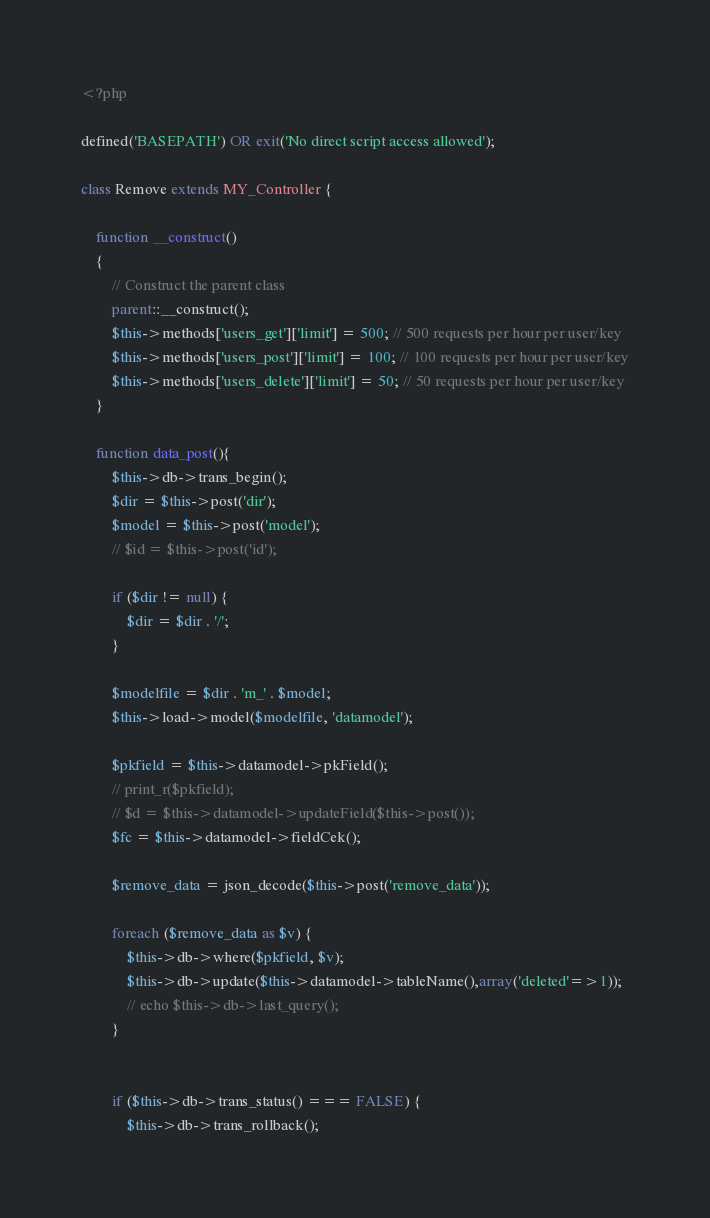<code> <loc_0><loc_0><loc_500><loc_500><_PHP_><?php

defined('BASEPATH') OR exit('No direct script access allowed');

class Remove extends MY_Controller {

    function __construct()
    {
        // Construct the parent class
        parent::__construct();
        $this->methods['users_get']['limit'] = 500; // 500 requests per hour per user/key
        $this->methods['users_post']['limit'] = 100; // 100 requests per hour per user/key
        $this->methods['users_delete']['limit'] = 50; // 50 requests per hour per user/key
    }

    function data_post(){
    	$this->db->trans_begin();
    	$dir = $this->post('dir');
    	$model = $this->post('model');
    	// $id = $this->post('id');

        if ($dir != null) {
            $dir = $dir . '/';
        }

        $modelfile = $dir . 'm_' . $model;
        $this->load->model($modelfile, 'datamodel');

        $pkfield = $this->datamodel->pkField();
        // print_r($pkfield);
        // $d = $this->datamodel->updateField($this->post());
        $fc = $this->datamodel->fieldCek();

        $remove_data = json_decode($this->post('remove_data'));

        foreach ($remove_data as $v) {
        	$this->db->where($pkfield, $v);
        	$this->db->update($this->datamodel->tableName(),array('deleted'=>1));
        	// echo $this->db->last_query();
        }
       

        if ($this->db->trans_status() === FALSE) {
            $this->db->trans_rollback();</code> 